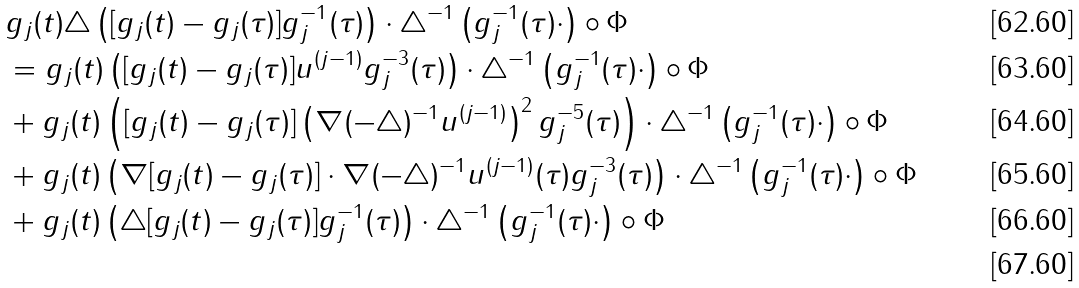<formula> <loc_0><loc_0><loc_500><loc_500>& g _ { j } ( t ) \triangle \left ( [ g _ { j } ( t ) - g _ { j } ( \tau ) ] g _ { j } ^ { - 1 } ( \tau ) \right ) \cdot \triangle ^ { - 1 } \left ( g _ { j } ^ { - 1 } ( \tau ) \cdot \right ) \circ \Phi \\ & = g _ { j } ( t ) \left ( [ g _ { j } ( t ) - g _ { j } ( \tau ) ] u ^ { ( j - 1 ) } g _ { j } ^ { - 3 } ( \tau ) \right ) \cdot \triangle ^ { - 1 } \left ( g _ { j } ^ { - 1 } ( \tau ) \cdot \right ) \circ \Phi \\ & + g _ { j } ( t ) \left ( [ g _ { j } ( t ) - g _ { j } ( \tau ) ] \left ( \nabla ( - \triangle ) ^ { - 1 } u ^ { ( j - 1 ) } \right ) ^ { 2 } g _ { j } ^ { - 5 } ( \tau ) \right ) \cdot \triangle ^ { - 1 } \left ( g _ { j } ^ { - 1 } ( \tau ) \cdot \right ) \circ \Phi \\ & + g _ { j } ( t ) \left ( \nabla [ g _ { j } ( t ) - g _ { j } ( \tau ) ] \cdot \nabla ( - \triangle ) ^ { - 1 } u ^ { ( j - 1 ) } ( \tau ) g _ { j } ^ { - 3 } ( \tau ) \right ) \cdot \triangle ^ { - 1 } \left ( g _ { j } ^ { - 1 } ( \tau ) \cdot \right ) \circ \Phi \\ & + g _ { j } ( t ) \left ( \triangle [ g _ { j } ( t ) - g _ { j } ( \tau ) ] g _ { j } ^ { - 1 } ( \tau ) \right ) \cdot \triangle ^ { - 1 } \left ( g _ { j } ^ { - 1 } ( \tau ) \cdot \right ) \circ \Phi \\</formula> 